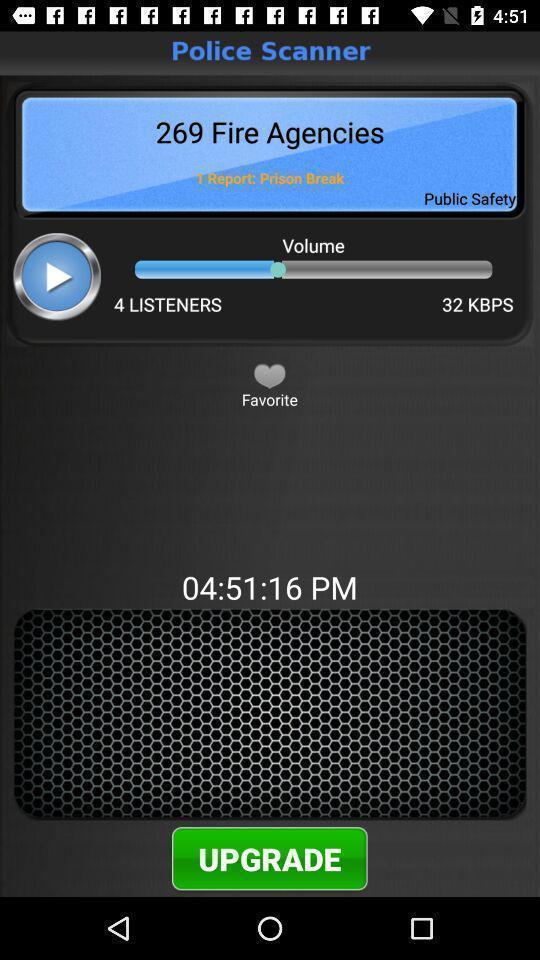Please provide a description for this image. Upgrade option showing in this page. 